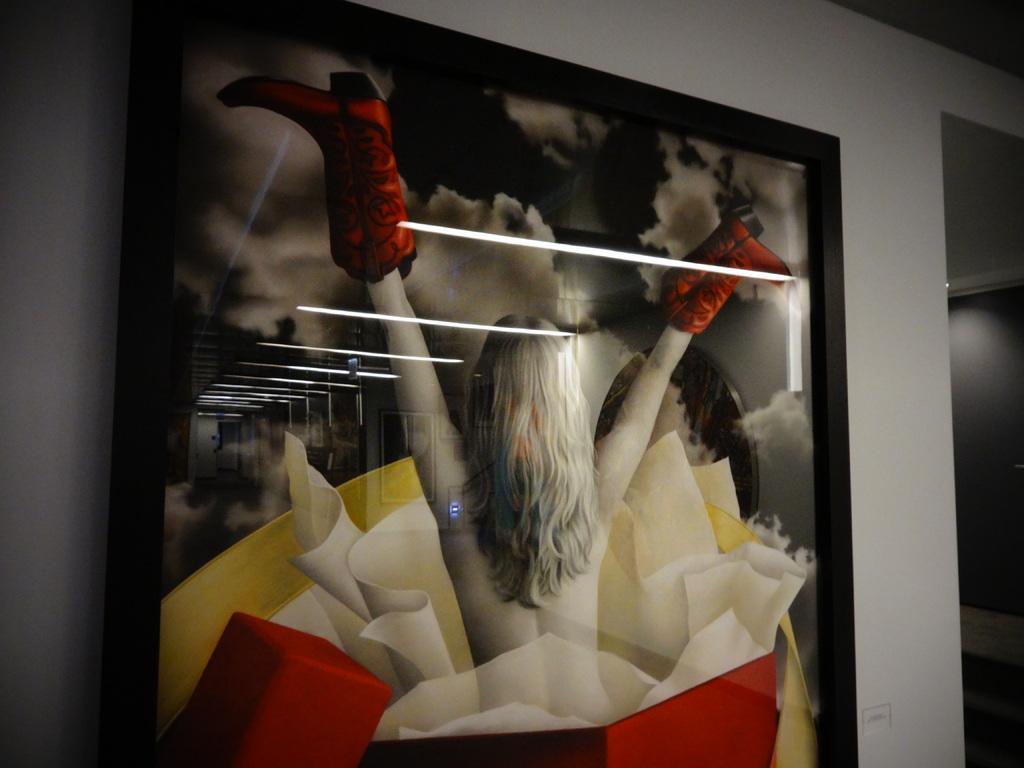Describe this image in one or two sentences. In this image we can see a photo on a wall. There are lamps reflections on the photo. A lady on a photo. 